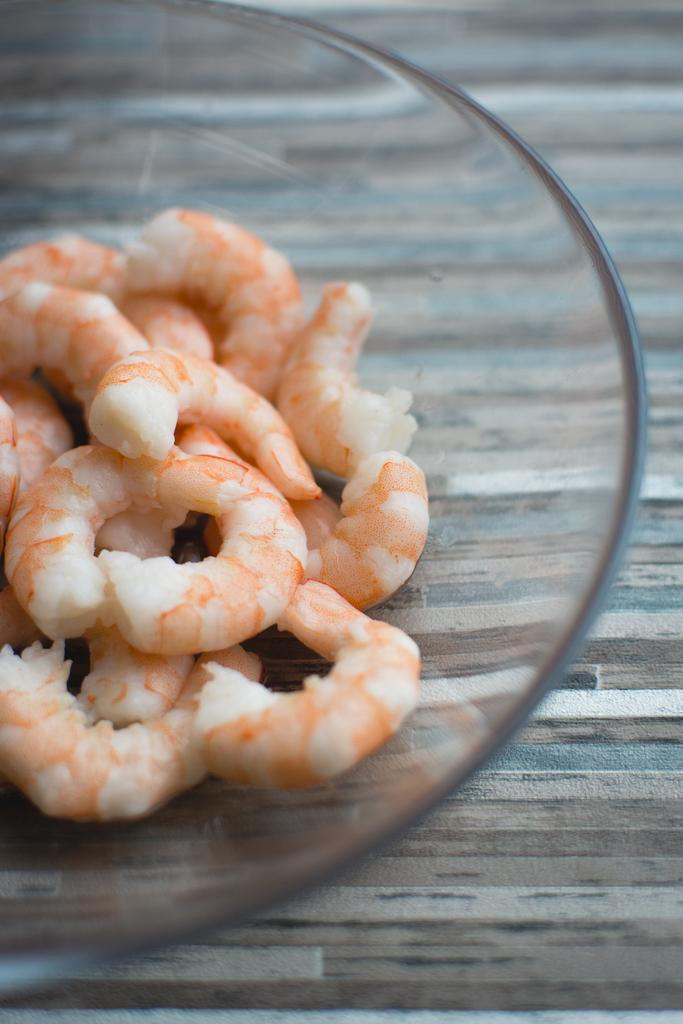What type of container is holding the food in the image? There is a glass bowl holding the food in the image. Can you describe the cloth in the image? There is a cloth at the bottom of the image. What color is the wing of the bird in the image? There is no bird or wing present in the image. 